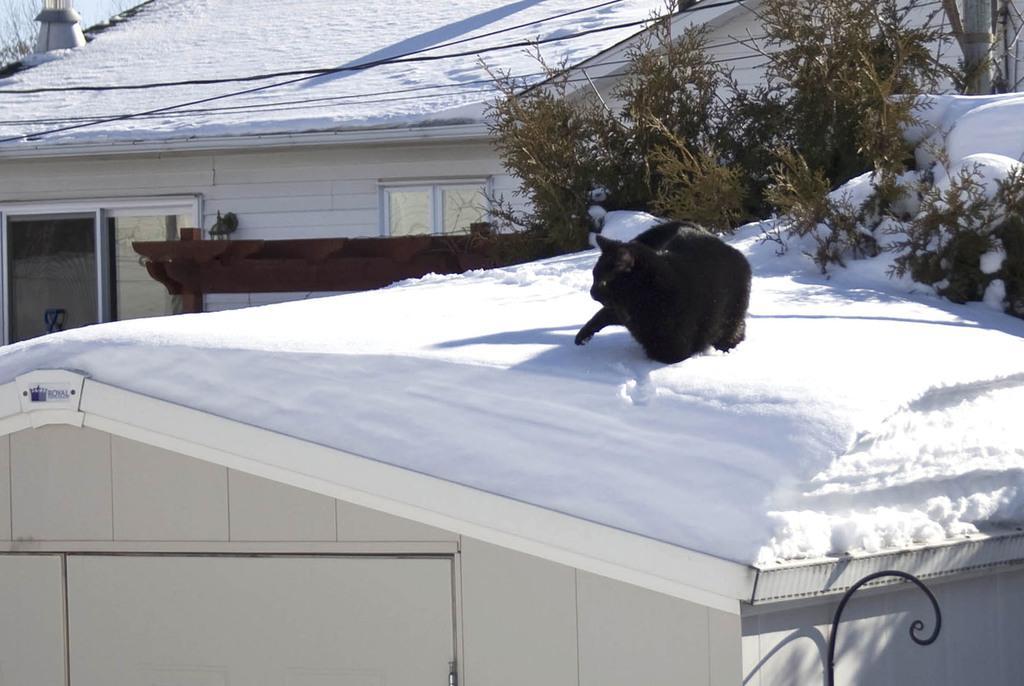Can you describe this image briefly? In this picture we can see the sky, houses, rooftops filled with the snow, transmission wires, trees, windows. We can see a black cat on the roof top. At the bottom portion of the picture we can see a black designed pole and it seems like the door of a house. 